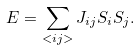<formula> <loc_0><loc_0><loc_500><loc_500>E = \sum _ { < i j > } J _ { i j } S _ { i } S _ { j } .</formula> 